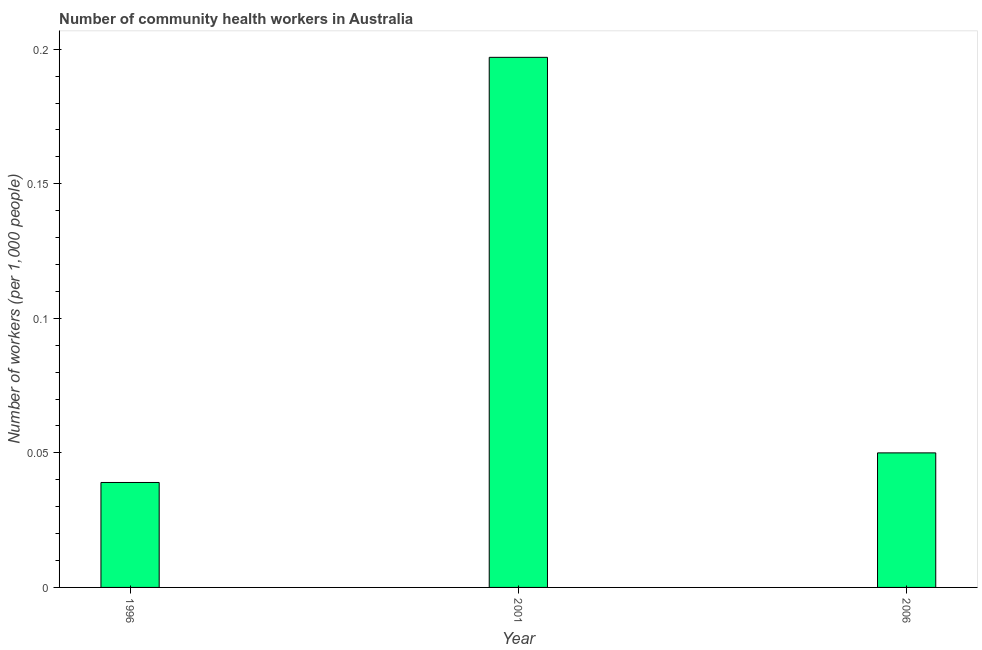Does the graph contain any zero values?
Your answer should be compact. No. What is the title of the graph?
Provide a succinct answer. Number of community health workers in Australia. What is the label or title of the Y-axis?
Provide a succinct answer. Number of workers (per 1,0 people). Across all years, what is the maximum number of community health workers?
Ensure brevity in your answer.  0.2. Across all years, what is the minimum number of community health workers?
Make the answer very short. 0.04. In which year was the number of community health workers maximum?
Give a very brief answer. 2001. What is the sum of the number of community health workers?
Make the answer very short. 0.29. What is the difference between the number of community health workers in 1996 and 2006?
Your answer should be very brief. -0.01. What is the average number of community health workers per year?
Provide a short and direct response. 0.1. What is the median number of community health workers?
Provide a succinct answer. 0.05. Do a majority of the years between 2001 and 1996 (inclusive) have number of community health workers greater than 0.11 ?
Make the answer very short. No. What is the ratio of the number of community health workers in 1996 to that in 2001?
Offer a very short reply. 0.2. Is the difference between the number of community health workers in 2001 and 2006 greater than the difference between any two years?
Give a very brief answer. No. What is the difference between the highest and the second highest number of community health workers?
Provide a short and direct response. 0.15. What is the difference between the highest and the lowest number of community health workers?
Your response must be concise. 0.16. In how many years, is the number of community health workers greater than the average number of community health workers taken over all years?
Your response must be concise. 1. What is the difference between two consecutive major ticks on the Y-axis?
Give a very brief answer. 0.05. Are the values on the major ticks of Y-axis written in scientific E-notation?
Keep it short and to the point. No. What is the Number of workers (per 1,000 people) of 1996?
Provide a succinct answer. 0.04. What is the Number of workers (per 1,000 people) in 2001?
Your answer should be very brief. 0.2. What is the difference between the Number of workers (per 1,000 people) in 1996 and 2001?
Ensure brevity in your answer.  -0.16. What is the difference between the Number of workers (per 1,000 people) in 1996 and 2006?
Your answer should be very brief. -0.01. What is the difference between the Number of workers (per 1,000 people) in 2001 and 2006?
Provide a succinct answer. 0.15. What is the ratio of the Number of workers (per 1,000 people) in 1996 to that in 2001?
Your answer should be compact. 0.2. What is the ratio of the Number of workers (per 1,000 people) in 1996 to that in 2006?
Your answer should be compact. 0.78. What is the ratio of the Number of workers (per 1,000 people) in 2001 to that in 2006?
Provide a short and direct response. 3.94. 